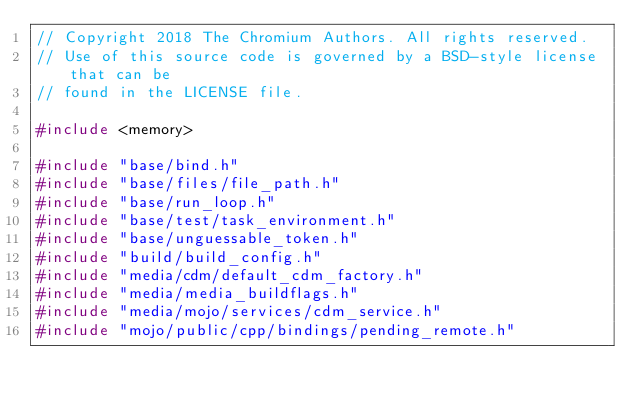<code> <loc_0><loc_0><loc_500><loc_500><_C++_>// Copyright 2018 The Chromium Authors. All rights reserved.
// Use of this source code is governed by a BSD-style license that can be
// found in the LICENSE file.

#include <memory>

#include "base/bind.h"
#include "base/files/file_path.h"
#include "base/run_loop.h"
#include "base/test/task_environment.h"
#include "base/unguessable_token.h"
#include "build/build_config.h"
#include "media/cdm/default_cdm_factory.h"
#include "media/media_buildflags.h"
#include "media/mojo/services/cdm_service.h"
#include "mojo/public/cpp/bindings/pending_remote.h"</code> 